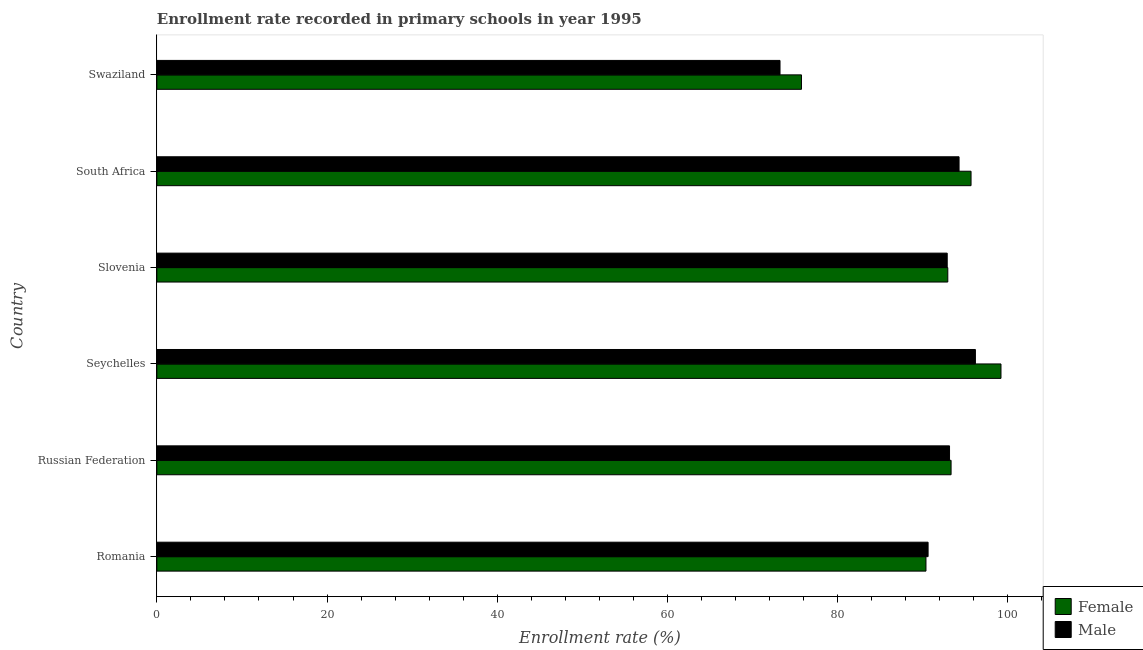How many different coloured bars are there?
Your response must be concise. 2. How many groups of bars are there?
Your answer should be very brief. 6. How many bars are there on the 6th tick from the bottom?
Provide a short and direct response. 2. What is the label of the 4th group of bars from the top?
Keep it short and to the point. Seychelles. In how many cases, is the number of bars for a given country not equal to the number of legend labels?
Make the answer very short. 0. What is the enrollment rate of female students in Slovenia?
Offer a very short reply. 92.93. Across all countries, what is the maximum enrollment rate of female students?
Your answer should be compact. 99.19. Across all countries, what is the minimum enrollment rate of male students?
Your response must be concise. 73.22. In which country was the enrollment rate of female students maximum?
Keep it short and to the point. Seychelles. In which country was the enrollment rate of male students minimum?
Make the answer very short. Swaziland. What is the total enrollment rate of male students in the graph?
Your answer should be compact. 540.29. What is the difference between the enrollment rate of male students in Seychelles and that in Slovenia?
Provide a short and direct response. 3.31. What is the difference between the enrollment rate of male students in Russian Federation and the enrollment rate of female students in Slovenia?
Make the answer very short. 0.2. What is the average enrollment rate of female students per country?
Offer a very short reply. 91.2. What is the difference between the enrollment rate of male students and enrollment rate of female students in Seychelles?
Your response must be concise. -3. What is the ratio of the enrollment rate of female students in Russian Federation to that in Seychelles?
Keep it short and to the point. 0.94. What is the difference between the highest and the second highest enrollment rate of female students?
Make the answer very short. 3.52. What is the difference between the highest and the lowest enrollment rate of female students?
Your answer should be compact. 23.44. How many legend labels are there?
Give a very brief answer. 2. How are the legend labels stacked?
Your response must be concise. Vertical. What is the title of the graph?
Your answer should be very brief. Enrollment rate recorded in primary schools in year 1995. What is the label or title of the X-axis?
Ensure brevity in your answer.  Enrollment rate (%). What is the label or title of the Y-axis?
Give a very brief answer. Country. What is the Enrollment rate (%) of Female in Romania?
Your answer should be compact. 90.37. What is the Enrollment rate (%) of Male in Romania?
Offer a very short reply. 90.62. What is the Enrollment rate (%) of Female in Russian Federation?
Make the answer very short. 93.32. What is the Enrollment rate (%) of Male in Russian Federation?
Provide a succinct answer. 93.14. What is the Enrollment rate (%) of Female in Seychelles?
Give a very brief answer. 99.19. What is the Enrollment rate (%) in Male in Seychelles?
Provide a short and direct response. 96.18. What is the Enrollment rate (%) in Female in Slovenia?
Offer a terse response. 92.93. What is the Enrollment rate (%) in Male in Slovenia?
Make the answer very short. 92.87. What is the Enrollment rate (%) in Female in South Africa?
Offer a very short reply. 95.67. What is the Enrollment rate (%) of Male in South Africa?
Your answer should be compact. 94.26. What is the Enrollment rate (%) in Female in Swaziland?
Provide a succinct answer. 75.74. What is the Enrollment rate (%) of Male in Swaziland?
Offer a very short reply. 73.22. Across all countries, what is the maximum Enrollment rate (%) in Female?
Offer a terse response. 99.19. Across all countries, what is the maximum Enrollment rate (%) in Male?
Your response must be concise. 96.18. Across all countries, what is the minimum Enrollment rate (%) in Female?
Provide a succinct answer. 75.74. Across all countries, what is the minimum Enrollment rate (%) in Male?
Make the answer very short. 73.22. What is the total Enrollment rate (%) in Female in the graph?
Offer a very short reply. 547.22. What is the total Enrollment rate (%) of Male in the graph?
Make the answer very short. 540.29. What is the difference between the Enrollment rate (%) in Female in Romania and that in Russian Federation?
Provide a succinct answer. -2.95. What is the difference between the Enrollment rate (%) in Male in Romania and that in Russian Federation?
Provide a short and direct response. -2.52. What is the difference between the Enrollment rate (%) of Female in Romania and that in Seychelles?
Your answer should be very brief. -8.81. What is the difference between the Enrollment rate (%) in Male in Romania and that in Seychelles?
Keep it short and to the point. -5.56. What is the difference between the Enrollment rate (%) in Female in Romania and that in Slovenia?
Keep it short and to the point. -2.56. What is the difference between the Enrollment rate (%) of Male in Romania and that in Slovenia?
Offer a terse response. -2.25. What is the difference between the Enrollment rate (%) of Female in Romania and that in South Africa?
Ensure brevity in your answer.  -5.3. What is the difference between the Enrollment rate (%) of Male in Romania and that in South Africa?
Provide a succinct answer. -3.64. What is the difference between the Enrollment rate (%) in Female in Romania and that in Swaziland?
Offer a very short reply. 14.63. What is the difference between the Enrollment rate (%) in Male in Romania and that in Swaziland?
Keep it short and to the point. 17.4. What is the difference between the Enrollment rate (%) of Female in Russian Federation and that in Seychelles?
Ensure brevity in your answer.  -5.86. What is the difference between the Enrollment rate (%) in Male in Russian Federation and that in Seychelles?
Make the answer very short. -3.04. What is the difference between the Enrollment rate (%) in Female in Russian Federation and that in Slovenia?
Provide a short and direct response. 0.39. What is the difference between the Enrollment rate (%) in Male in Russian Federation and that in Slovenia?
Offer a very short reply. 0.27. What is the difference between the Enrollment rate (%) in Female in Russian Federation and that in South Africa?
Keep it short and to the point. -2.35. What is the difference between the Enrollment rate (%) of Male in Russian Federation and that in South Africa?
Make the answer very short. -1.12. What is the difference between the Enrollment rate (%) in Female in Russian Federation and that in Swaziland?
Keep it short and to the point. 17.58. What is the difference between the Enrollment rate (%) of Male in Russian Federation and that in Swaziland?
Give a very brief answer. 19.92. What is the difference between the Enrollment rate (%) of Female in Seychelles and that in Slovenia?
Give a very brief answer. 6.25. What is the difference between the Enrollment rate (%) of Male in Seychelles and that in Slovenia?
Give a very brief answer. 3.31. What is the difference between the Enrollment rate (%) of Female in Seychelles and that in South Africa?
Ensure brevity in your answer.  3.52. What is the difference between the Enrollment rate (%) of Male in Seychelles and that in South Africa?
Offer a very short reply. 1.92. What is the difference between the Enrollment rate (%) of Female in Seychelles and that in Swaziland?
Provide a short and direct response. 23.44. What is the difference between the Enrollment rate (%) in Male in Seychelles and that in Swaziland?
Offer a terse response. 22.96. What is the difference between the Enrollment rate (%) of Female in Slovenia and that in South Africa?
Your response must be concise. -2.73. What is the difference between the Enrollment rate (%) in Male in Slovenia and that in South Africa?
Make the answer very short. -1.39. What is the difference between the Enrollment rate (%) of Female in Slovenia and that in Swaziland?
Make the answer very short. 17.19. What is the difference between the Enrollment rate (%) of Male in Slovenia and that in Swaziland?
Your answer should be very brief. 19.65. What is the difference between the Enrollment rate (%) of Female in South Africa and that in Swaziland?
Your answer should be compact. 19.92. What is the difference between the Enrollment rate (%) of Male in South Africa and that in Swaziland?
Provide a succinct answer. 21.04. What is the difference between the Enrollment rate (%) of Female in Romania and the Enrollment rate (%) of Male in Russian Federation?
Provide a short and direct response. -2.77. What is the difference between the Enrollment rate (%) in Female in Romania and the Enrollment rate (%) in Male in Seychelles?
Your answer should be compact. -5.81. What is the difference between the Enrollment rate (%) in Female in Romania and the Enrollment rate (%) in Male in Slovenia?
Keep it short and to the point. -2.5. What is the difference between the Enrollment rate (%) of Female in Romania and the Enrollment rate (%) of Male in South Africa?
Give a very brief answer. -3.89. What is the difference between the Enrollment rate (%) of Female in Romania and the Enrollment rate (%) of Male in Swaziland?
Your answer should be compact. 17.15. What is the difference between the Enrollment rate (%) in Female in Russian Federation and the Enrollment rate (%) in Male in Seychelles?
Provide a succinct answer. -2.86. What is the difference between the Enrollment rate (%) of Female in Russian Federation and the Enrollment rate (%) of Male in Slovenia?
Keep it short and to the point. 0.45. What is the difference between the Enrollment rate (%) of Female in Russian Federation and the Enrollment rate (%) of Male in South Africa?
Make the answer very short. -0.94. What is the difference between the Enrollment rate (%) in Female in Russian Federation and the Enrollment rate (%) in Male in Swaziland?
Ensure brevity in your answer.  20.1. What is the difference between the Enrollment rate (%) of Female in Seychelles and the Enrollment rate (%) of Male in Slovenia?
Provide a short and direct response. 6.32. What is the difference between the Enrollment rate (%) of Female in Seychelles and the Enrollment rate (%) of Male in South Africa?
Give a very brief answer. 4.93. What is the difference between the Enrollment rate (%) of Female in Seychelles and the Enrollment rate (%) of Male in Swaziland?
Provide a short and direct response. 25.96. What is the difference between the Enrollment rate (%) in Female in Slovenia and the Enrollment rate (%) in Male in South Africa?
Ensure brevity in your answer.  -1.32. What is the difference between the Enrollment rate (%) of Female in Slovenia and the Enrollment rate (%) of Male in Swaziland?
Your response must be concise. 19.71. What is the difference between the Enrollment rate (%) of Female in South Africa and the Enrollment rate (%) of Male in Swaziland?
Offer a terse response. 22.45. What is the average Enrollment rate (%) in Female per country?
Your response must be concise. 91.2. What is the average Enrollment rate (%) of Male per country?
Your answer should be very brief. 90.05. What is the difference between the Enrollment rate (%) of Female and Enrollment rate (%) of Male in Romania?
Ensure brevity in your answer.  -0.25. What is the difference between the Enrollment rate (%) in Female and Enrollment rate (%) in Male in Russian Federation?
Your answer should be very brief. 0.18. What is the difference between the Enrollment rate (%) of Female and Enrollment rate (%) of Male in Seychelles?
Keep it short and to the point. 3.01. What is the difference between the Enrollment rate (%) of Female and Enrollment rate (%) of Male in Slovenia?
Keep it short and to the point. 0.07. What is the difference between the Enrollment rate (%) in Female and Enrollment rate (%) in Male in South Africa?
Offer a very short reply. 1.41. What is the difference between the Enrollment rate (%) in Female and Enrollment rate (%) in Male in Swaziland?
Provide a succinct answer. 2.52. What is the ratio of the Enrollment rate (%) in Female in Romania to that in Russian Federation?
Your answer should be compact. 0.97. What is the ratio of the Enrollment rate (%) in Female in Romania to that in Seychelles?
Offer a very short reply. 0.91. What is the ratio of the Enrollment rate (%) of Male in Romania to that in Seychelles?
Your answer should be compact. 0.94. What is the ratio of the Enrollment rate (%) in Female in Romania to that in Slovenia?
Your answer should be very brief. 0.97. What is the ratio of the Enrollment rate (%) in Male in Romania to that in Slovenia?
Your answer should be very brief. 0.98. What is the ratio of the Enrollment rate (%) in Female in Romania to that in South Africa?
Provide a short and direct response. 0.94. What is the ratio of the Enrollment rate (%) in Male in Romania to that in South Africa?
Your response must be concise. 0.96. What is the ratio of the Enrollment rate (%) in Female in Romania to that in Swaziland?
Give a very brief answer. 1.19. What is the ratio of the Enrollment rate (%) in Male in Romania to that in Swaziland?
Your answer should be very brief. 1.24. What is the ratio of the Enrollment rate (%) in Female in Russian Federation to that in Seychelles?
Provide a succinct answer. 0.94. What is the ratio of the Enrollment rate (%) in Male in Russian Federation to that in Seychelles?
Your answer should be very brief. 0.97. What is the ratio of the Enrollment rate (%) of Female in Russian Federation to that in South Africa?
Offer a terse response. 0.98. What is the ratio of the Enrollment rate (%) of Male in Russian Federation to that in South Africa?
Your answer should be very brief. 0.99. What is the ratio of the Enrollment rate (%) in Female in Russian Federation to that in Swaziland?
Offer a very short reply. 1.23. What is the ratio of the Enrollment rate (%) of Male in Russian Federation to that in Swaziland?
Make the answer very short. 1.27. What is the ratio of the Enrollment rate (%) in Female in Seychelles to that in Slovenia?
Offer a terse response. 1.07. What is the ratio of the Enrollment rate (%) in Male in Seychelles to that in Slovenia?
Provide a short and direct response. 1.04. What is the ratio of the Enrollment rate (%) of Female in Seychelles to that in South Africa?
Your response must be concise. 1.04. What is the ratio of the Enrollment rate (%) of Male in Seychelles to that in South Africa?
Give a very brief answer. 1.02. What is the ratio of the Enrollment rate (%) in Female in Seychelles to that in Swaziland?
Your answer should be compact. 1.31. What is the ratio of the Enrollment rate (%) in Male in Seychelles to that in Swaziland?
Offer a terse response. 1.31. What is the ratio of the Enrollment rate (%) of Female in Slovenia to that in South Africa?
Your answer should be very brief. 0.97. What is the ratio of the Enrollment rate (%) in Male in Slovenia to that in South Africa?
Give a very brief answer. 0.99. What is the ratio of the Enrollment rate (%) of Female in Slovenia to that in Swaziland?
Ensure brevity in your answer.  1.23. What is the ratio of the Enrollment rate (%) of Male in Slovenia to that in Swaziland?
Give a very brief answer. 1.27. What is the ratio of the Enrollment rate (%) in Female in South Africa to that in Swaziland?
Offer a terse response. 1.26. What is the ratio of the Enrollment rate (%) in Male in South Africa to that in Swaziland?
Your response must be concise. 1.29. What is the difference between the highest and the second highest Enrollment rate (%) in Female?
Your response must be concise. 3.52. What is the difference between the highest and the second highest Enrollment rate (%) of Male?
Your answer should be compact. 1.92. What is the difference between the highest and the lowest Enrollment rate (%) of Female?
Keep it short and to the point. 23.44. What is the difference between the highest and the lowest Enrollment rate (%) of Male?
Make the answer very short. 22.96. 